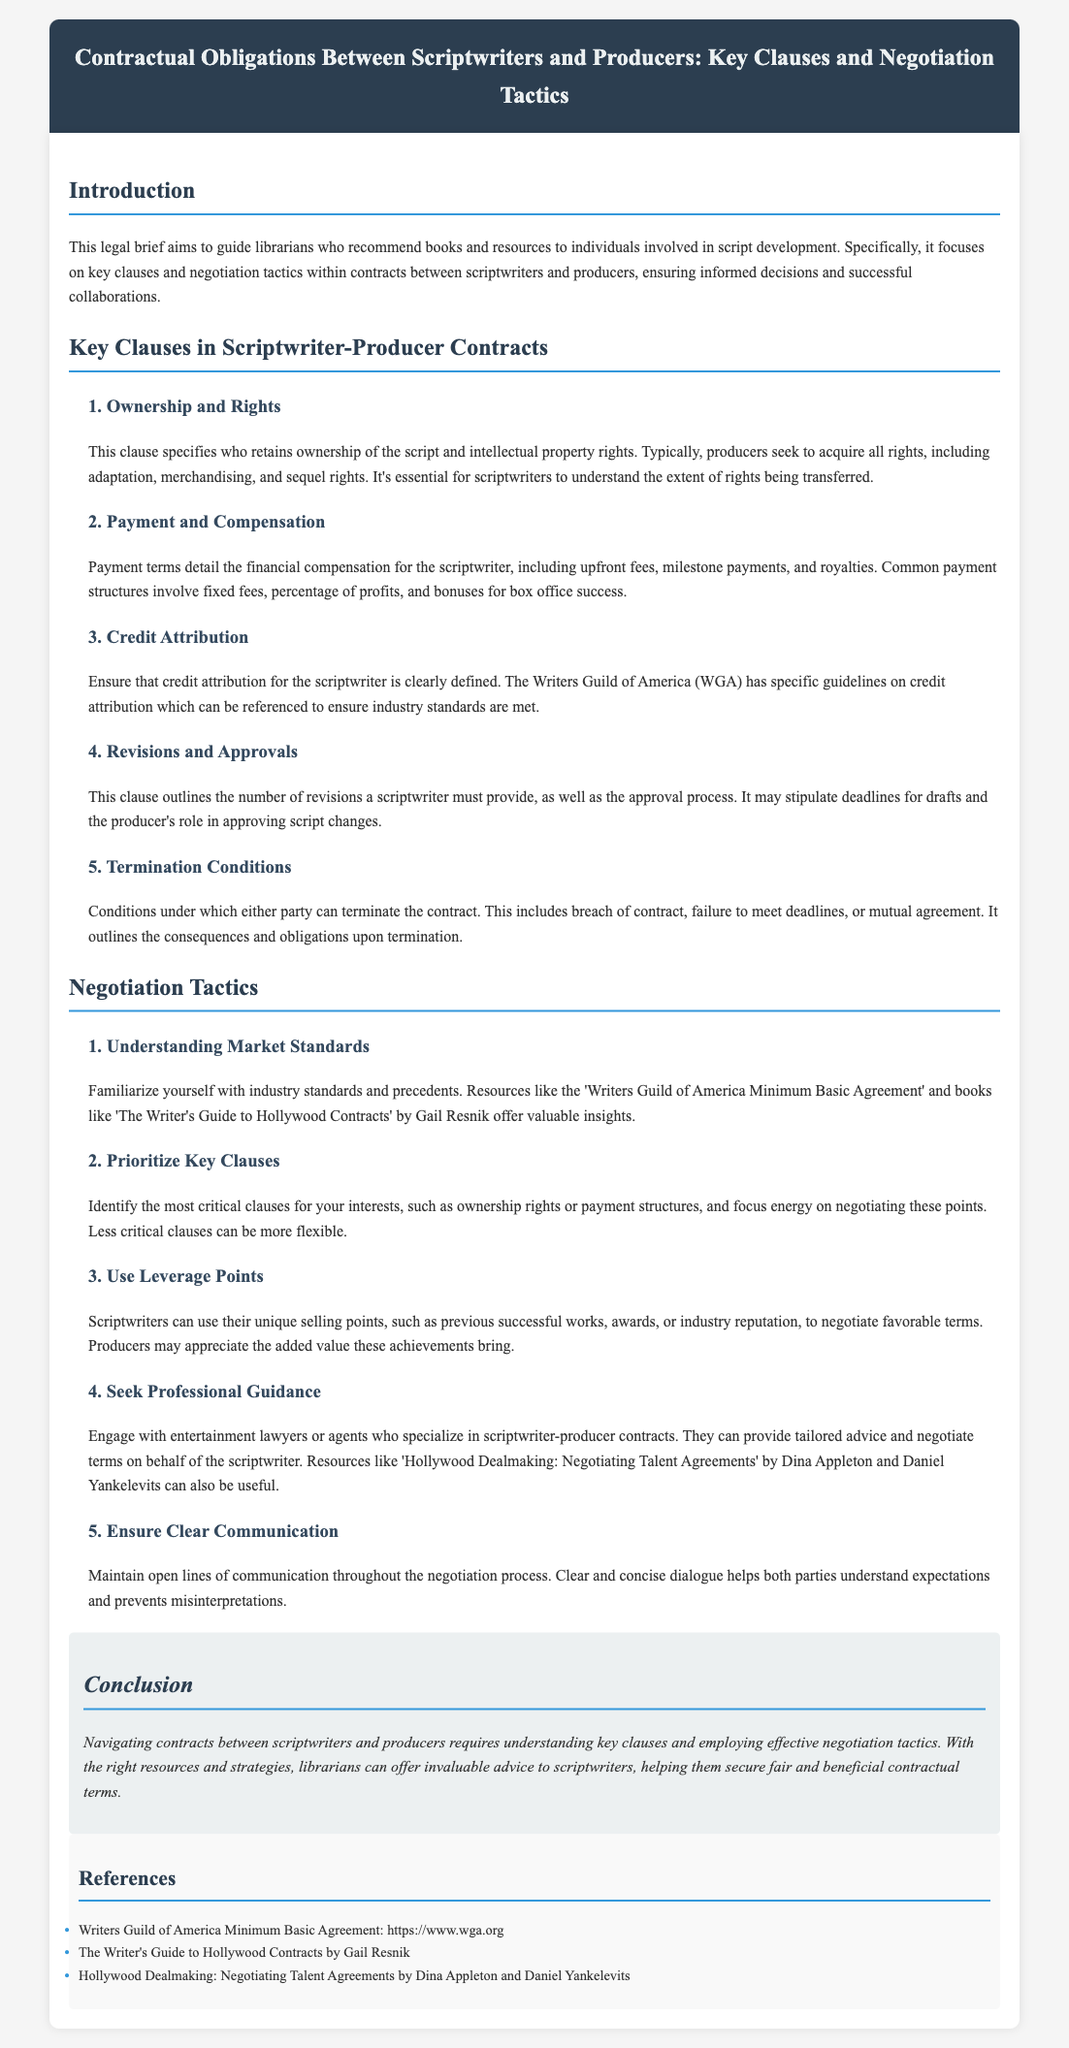What is the main topic of the legal brief? The main topic focuses on contractual obligations between scriptwriters and producers, particularly key clauses and negotiation tactics.
Answer: Contractual obligations between scriptwriters and producers What is one key clause mentioned in the document? The document outlines several key clauses including ownership and rights, among others.
Answer: Ownership and rights Who is a recommended resource for understanding industry standards? The document suggests resources like the Writers Guild of America Minimum Basic Agreement to familiarize with industry standards.
Answer: Writers Guild of America Minimum Basic Agreement What does the Payment and Compensation clause detail? It explains the financial compensation for the scriptwriter, encompassing various payment structures.
Answer: Financial compensation for the scriptwriter What is one negotiation tactic mentioned in the brief? The brief lists several tactics, including prioritizing key clauses for negotiation.
Answer: Prioritize key clauses How can a scriptwriter use leverage in negotiations? The brief specifies that scriptwriters can use their unique selling points as leverage during negotiations.
Answer: Unique selling points Which book is suggested for understanding Hollywood contracts? The document refers to 'The Writer's Guide to Hollywood Contracts' as a valuable resource.
Answer: The Writer's Guide to Hollywood Contracts What does the clause regarding Termination Conditions outline? This clause specifies the conditions under which either party can terminate the contract.
Answer: Conditions for contract termination What is a crucial part of the Revisions and Approvals clause? The document indicates it outlines the number of revisions and the approval process necessary for the script.
Answer: Number of revisions and approval process 